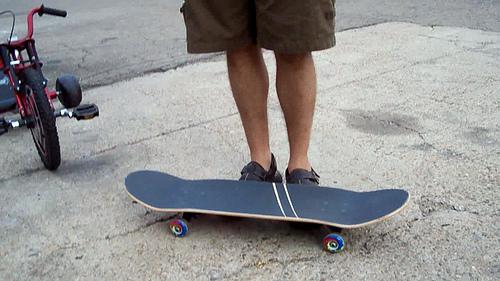How many wheels do you see?
Answer briefly. 3. What object is by the man's feet?
Keep it brief. Skateboard. What type of shorts is the boy wearing?
Be succinct. Cargo. 